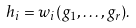Convert formula to latex. <formula><loc_0><loc_0><loc_500><loc_500>h _ { i } = w _ { i } ( g _ { 1 } , \dots , g _ { r } ) .</formula> 